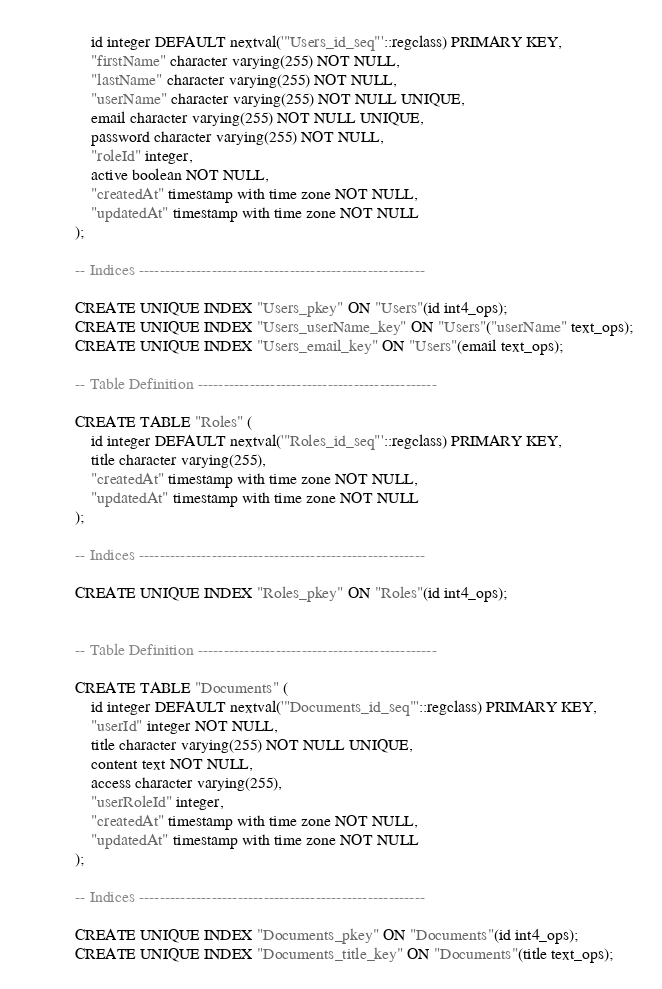<code> <loc_0><loc_0><loc_500><loc_500><_SQL_>    id integer DEFAULT nextval('"Users_id_seq"'::regclass) PRIMARY KEY,
    "firstName" character varying(255) NOT NULL,
    "lastName" character varying(255) NOT NULL,
    "userName" character varying(255) NOT NULL UNIQUE,
    email character varying(255) NOT NULL UNIQUE,
    password character varying(255) NOT NULL,
    "roleId" integer,
    active boolean NOT NULL,
    "createdAt" timestamp with time zone NOT NULL,
    "updatedAt" timestamp with time zone NOT NULL
);

-- Indices -------------------------------------------------------

CREATE UNIQUE INDEX "Users_pkey" ON "Users"(id int4_ops);
CREATE UNIQUE INDEX "Users_userName_key" ON "Users"("userName" text_ops);
CREATE UNIQUE INDEX "Users_email_key" ON "Users"(email text_ops);

-- Table Definition ----------------------------------------------

CREATE TABLE "Roles" (
    id integer DEFAULT nextval('"Roles_id_seq"'::regclass) PRIMARY KEY,
    title character varying(255),
    "createdAt" timestamp with time zone NOT NULL,
    "updatedAt" timestamp with time zone NOT NULL
);

-- Indices -------------------------------------------------------

CREATE UNIQUE INDEX "Roles_pkey" ON "Roles"(id int4_ops);


-- Table Definition ----------------------------------------------

CREATE TABLE "Documents" (
    id integer DEFAULT nextval('"Documents_id_seq"'::regclass) PRIMARY KEY,
    "userId" integer NOT NULL,
    title character varying(255) NOT NULL UNIQUE,
    content text NOT NULL,
    access character varying(255),
    "userRoleId" integer,
    "createdAt" timestamp with time zone NOT NULL,
    "updatedAt" timestamp with time zone NOT NULL
);

-- Indices -------------------------------------------------------

CREATE UNIQUE INDEX "Documents_pkey" ON "Documents"(id int4_ops);
CREATE UNIQUE INDEX "Documents_title_key" ON "Documents"(title text_ops);
</code> 